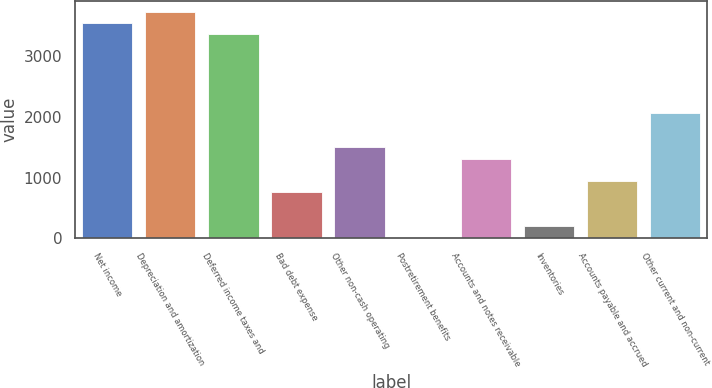Convert chart. <chart><loc_0><loc_0><loc_500><loc_500><bar_chart><fcel>Net income<fcel>Depreciation and amortization<fcel>Deferred income taxes and<fcel>Bad debt expense<fcel>Other non-cash operating<fcel>Postretirement benefits<fcel>Accounts and notes receivable<fcel>Inventories<fcel>Accounts payable and accrued<fcel>Other current and non-current<nl><fcel>3538.4<fcel>3724<fcel>3352.8<fcel>754.4<fcel>1496.8<fcel>12<fcel>1311.2<fcel>197.6<fcel>940<fcel>2053.6<nl></chart> 